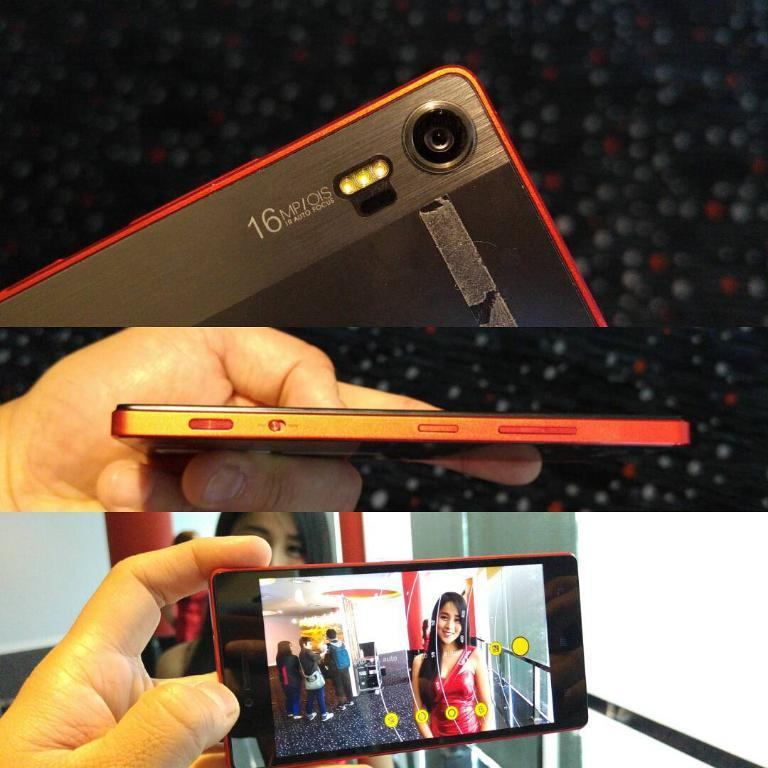<image>
Summarize the visual content of the image. A red phone has the label 16MP on the side. 